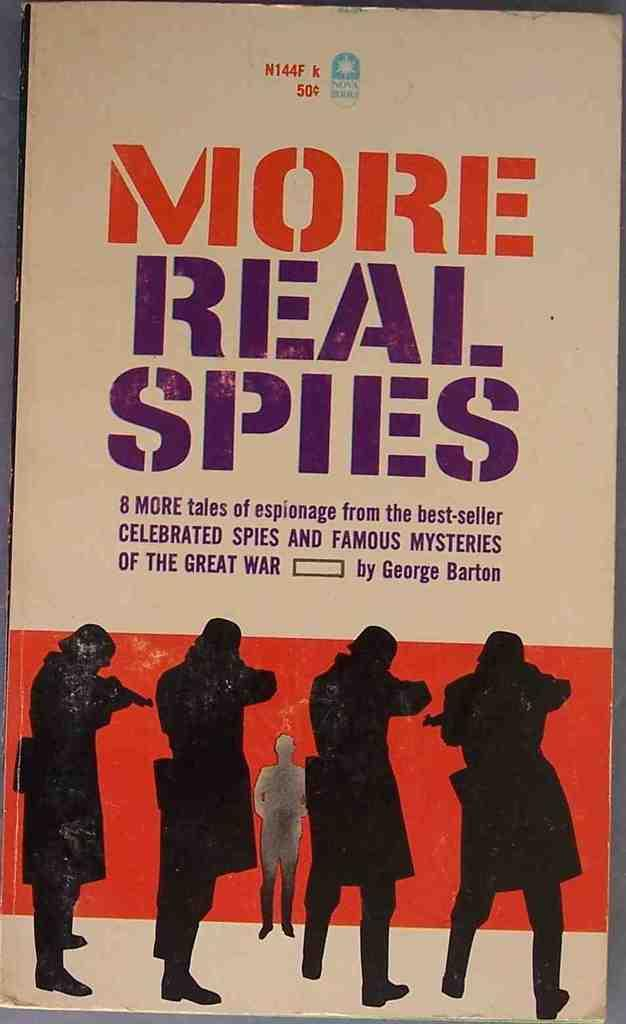What type of visual is the image? The image is a poster. What can be found on the poster besides the depictions of people? There is writing on the poster. Can you describe the people depicted on the poster? The poster contains depictions of people, but no specific details are provided. What type of beast is depicted on the poster? There is no beast depicted on the poster; it contains depictions of people and writing. Is there a lock visible on the poster? There is no mention of a lock in the provided facts, so it cannot be determined if one is present on the poster. 